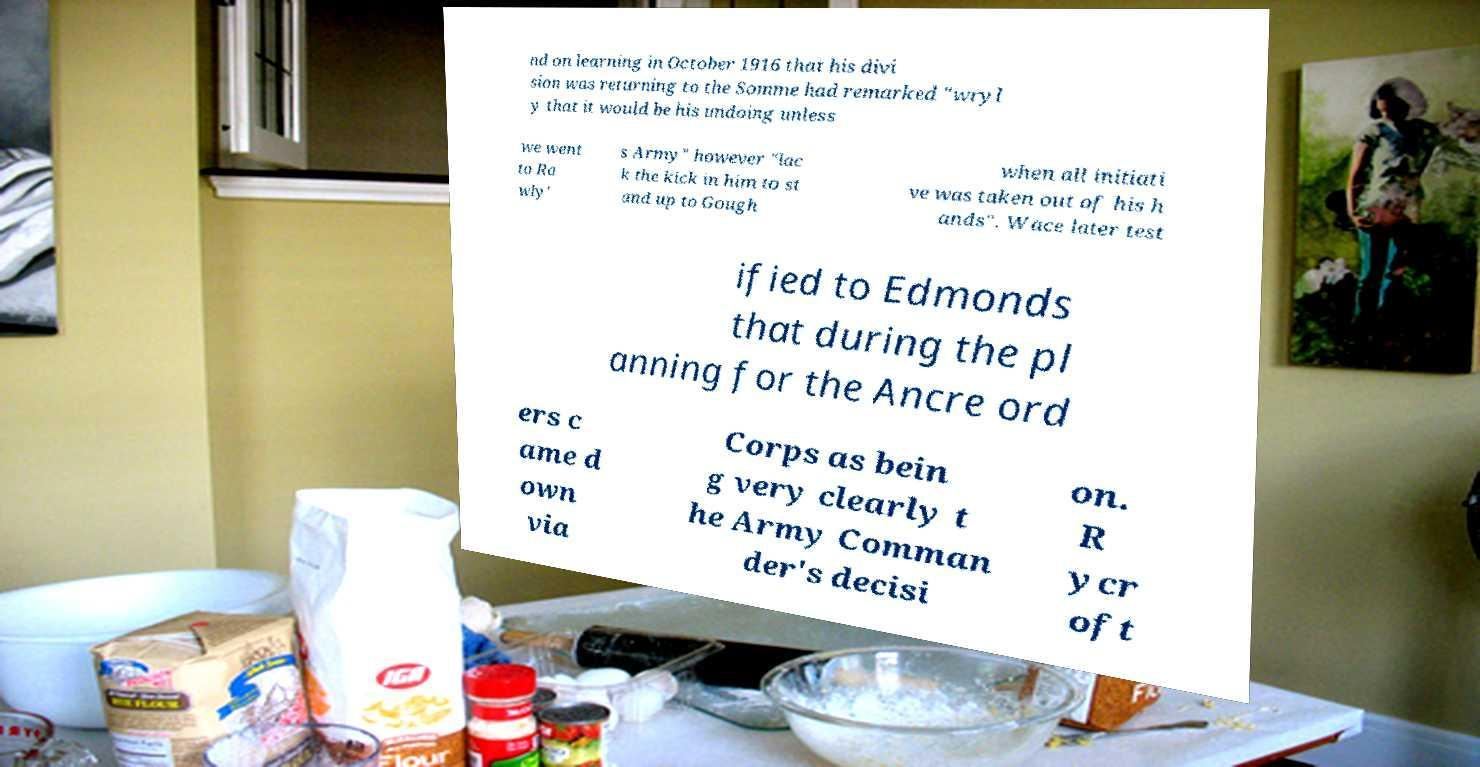Can you read and provide the text displayed in the image?This photo seems to have some interesting text. Can you extract and type it out for me? nd on learning in October 1916 that his divi sion was returning to the Somme had remarked "wryl y that it would be his undoing unless we went to Ra wly' s Army" however "lac k the kick in him to st and up to Gough when all initiati ve was taken out of his h ands". Wace later test ified to Edmonds that during the pl anning for the Ancre ord ers c ame d own via Corps as bein g very clearly t he Army Comman der's decisi on. R ycr oft 